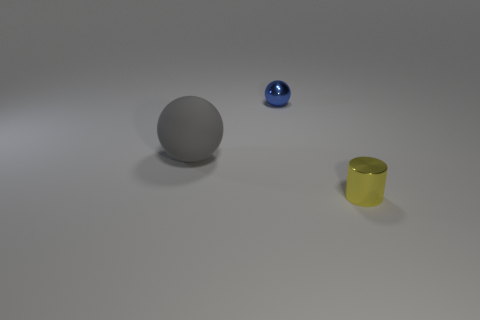Add 3 metal cylinders. How many objects exist? 6 Subtract all spheres. How many objects are left? 1 Add 1 yellow cylinders. How many yellow cylinders exist? 2 Subtract 0 green blocks. How many objects are left? 3 Subtract all matte balls. Subtract all yellow things. How many objects are left? 1 Add 3 yellow shiny objects. How many yellow shiny objects are left? 4 